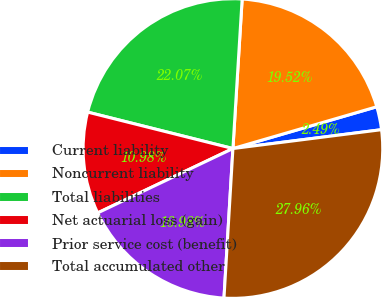Convert chart. <chart><loc_0><loc_0><loc_500><loc_500><pie_chart><fcel>Current liability<fcel>Noncurrent liability<fcel>Total liabilities<fcel>Net actuarial loss (gain)<fcel>Prior service cost (benefit)<fcel>Total accumulated other<nl><fcel>2.49%<fcel>19.52%<fcel>22.07%<fcel>10.98%<fcel>16.98%<fcel>27.96%<nl></chart> 